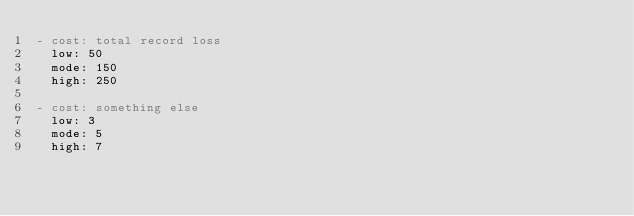Convert code to text. <code><loc_0><loc_0><loc_500><loc_500><_YAML_>- cost: total record loss
  low: 50
  mode: 150
  high: 250

- cost: something else 
  low: 3
  mode: 5
  high: 7 
</code> 